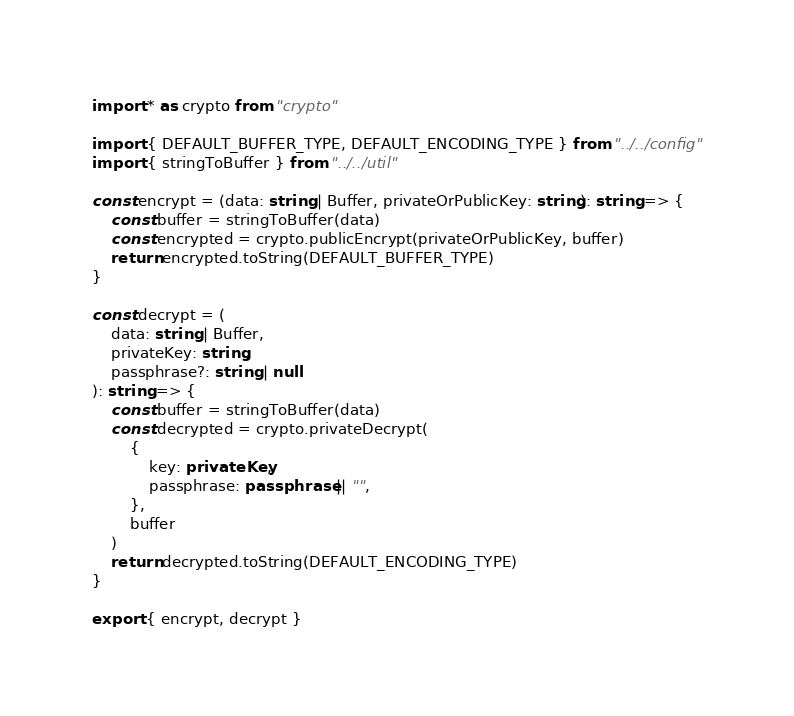<code> <loc_0><loc_0><loc_500><loc_500><_TypeScript_>import * as crypto from "crypto"

import { DEFAULT_BUFFER_TYPE, DEFAULT_ENCODING_TYPE } from "../../config"
import { stringToBuffer } from "../../util"

const encrypt = (data: string | Buffer, privateOrPublicKey: string): string => {
    const buffer = stringToBuffer(data)
    const encrypted = crypto.publicEncrypt(privateOrPublicKey, buffer)
    return encrypted.toString(DEFAULT_BUFFER_TYPE)
}

const decrypt = (
    data: string | Buffer,
    privateKey: string,
    passphrase?: string | null
): string => {
    const buffer = stringToBuffer(data)
    const decrypted = crypto.privateDecrypt(
        {
            key: privateKey,
            passphrase: passphrase || "",
        },
        buffer
    )
    return decrypted.toString(DEFAULT_ENCODING_TYPE)
}

export { encrypt, decrypt }
</code> 